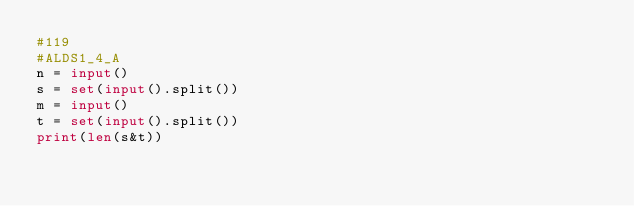<code> <loc_0><loc_0><loc_500><loc_500><_Python_>#119
#ALDS1_4_A
n = input()
s = set(input().split())
m = input()
t = set(input().split())
print(len(s&t))


</code> 